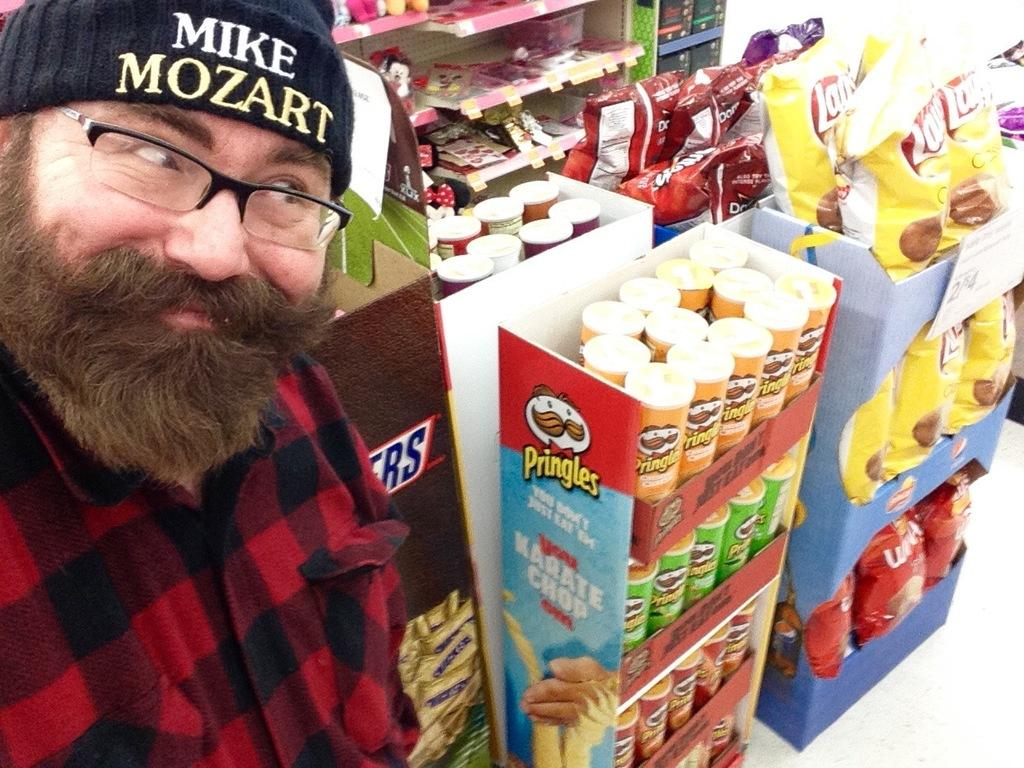What is the main subject of the image? The main subject of the image is a man. Can you describe the man's appearance? The man is wearing glasses and a cap. What is the man's facial expression? The man is smiling. What else can be seen in the image besides the man? There are packets and boxes in the image. What is visible in the background of the image? There are objects in racks in the background of the image. What type of chin can be seen on the man in the image? There is no mention of the man's chin in the provided facts, so it cannot be determined from the image. Can you describe how the man turns in the image? There is no indication that the man is turning in the image; he is facing forward. 